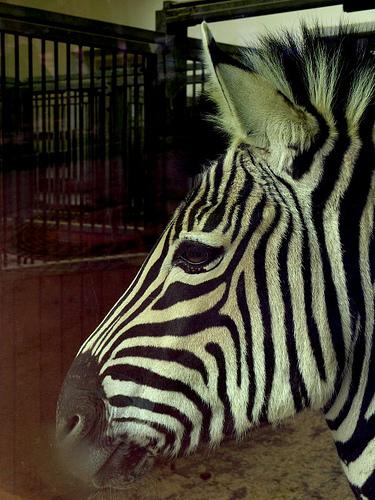Where is the Zebra?
Keep it brief. Zoo. Does the zebra look happy?
Short answer required. Yes. How many lines are on the zebra?
Keep it brief. 22. Where is the zebra?
Quick response, please. Zoo. 